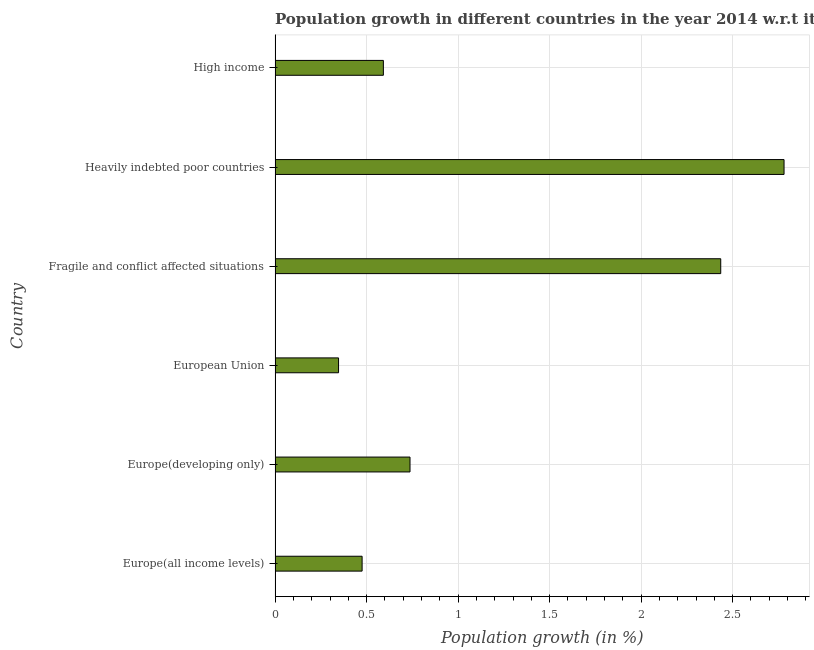Does the graph contain any zero values?
Give a very brief answer. No. Does the graph contain grids?
Offer a terse response. Yes. What is the title of the graph?
Offer a terse response. Population growth in different countries in the year 2014 w.r.t it's previous year. What is the label or title of the X-axis?
Your response must be concise. Population growth (in %). What is the population growth in Heavily indebted poor countries?
Provide a succinct answer. 2.78. Across all countries, what is the maximum population growth?
Your answer should be very brief. 2.78. Across all countries, what is the minimum population growth?
Keep it short and to the point. 0.35. In which country was the population growth maximum?
Give a very brief answer. Heavily indebted poor countries. What is the sum of the population growth?
Your answer should be very brief. 7.37. What is the difference between the population growth in Europe(developing only) and European Union?
Provide a succinct answer. 0.39. What is the average population growth per country?
Your answer should be compact. 1.23. What is the median population growth?
Your answer should be very brief. 0.66. What is the ratio of the population growth in European Union to that in Fragile and conflict affected situations?
Keep it short and to the point. 0.14. Is the population growth in Europe(all income levels) less than that in European Union?
Provide a succinct answer. No. What is the difference between the highest and the second highest population growth?
Make the answer very short. 0.35. Is the sum of the population growth in European Union and Heavily indebted poor countries greater than the maximum population growth across all countries?
Ensure brevity in your answer.  Yes. What is the difference between the highest and the lowest population growth?
Your response must be concise. 2.43. What is the difference between two consecutive major ticks on the X-axis?
Ensure brevity in your answer.  0.5. What is the Population growth (in %) in Europe(all income levels)?
Your response must be concise. 0.48. What is the Population growth (in %) of Europe(developing only)?
Your answer should be compact. 0.74. What is the Population growth (in %) of European Union?
Keep it short and to the point. 0.35. What is the Population growth (in %) in Fragile and conflict affected situations?
Ensure brevity in your answer.  2.43. What is the Population growth (in %) of Heavily indebted poor countries?
Offer a terse response. 2.78. What is the Population growth (in %) in High income?
Keep it short and to the point. 0.59. What is the difference between the Population growth (in %) in Europe(all income levels) and Europe(developing only)?
Your response must be concise. -0.26. What is the difference between the Population growth (in %) in Europe(all income levels) and European Union?
Ensure brevity in your answer.  0.13. What is the difference between the Population growth (in %) in Europe(all income levels) and Fragile and conflict affected situations?
Your response must be concise. -1.96. What is the difference between the Population growth (in %) in Europe(all income levels) and Heavily indebted poor countries?
Provide a succinct answer. -2.31. What is the difference between the Population growth (in %) in Europe(all income levels) and High income?
Your answer should be compact. -0.12. What is the difference between the Population growth (in %) in Europe(developing only) and European Union?
Give a very brief answer. 0.39. What is the difference between the Population growth (in %) in Europe(developing only) and Fragile and conflict affected situations?
Give a very brief answer. -1.7. What is the difference between the Population growth (in %) in Europe(developing only) and Heavily indebted poor countries?
Your answer should be compact. -2.04. What is the difference between the Population growth (in %) in Europe(developing only) and High income?
Offer a very short reply. 0.15. What is the difference between the Population growth (in %) in European Union and Fragile and conflict affected situations?
Your answer should be compact. -2.09. What is the difference between the Population growth (in %) in European Union and Heavily indebted poor countries?
Ensure brevity in your answer.  -2.43. What is the difference between the Population growth (in %) in European Union and High income?
Give a very brief answer. -0.24. What is the difference between the Population growth (in %) in Fragile and conflict affected situations and Heavily indebted poor countries?
Your answer should be very brief. -0.35. What is the difference between the Population growth (in %) in Fragile and conflict affected situations and High income?
Provide a short and direct response. 1.84. What is the difference between the Population growth (in %) in Heavily indebted poor countries and High income?
Keep it short and to the point. 2.19. What is the ratio of the Population growth (in %) in Europe(all income levels) to that in Europe(developing only)?
Ensure brevity in your answer.  0.65. What is the ratio of the Population growth (in %) in Europe(all income levels) to that in European Union?
Your answer should be very brief. 1.37. What is the ratio of the Population growth (in %) in Europe(all income levels) to that in Fragile and conflict affected situations?
Provide a succinct answer. 0.2. What is the ratio of the Population growth (in %) in Europe(all income levels) to that in Heavily indebted poor countries?
Ensure brevity in your answer.  0.17. What is the ratio of the Population growth (in %) in Europe(all income levels) to that in High income?
Give a very brief answer. 0.8. What is the ratio of the Population growth (in %) in Europe(developing only) to that in European Union?
Offer a very short reply. 2.13. What is the ratio of the Population growth (in %) in Europe(developing only) to that in Fragile and conflict affected situations?
Provide a short and direct response. 0.3. What is the ratio of the Population growth (in %) in Europe(developing only) to that in Heavily indebted poor countries?
Give a very brief answer. 0.27. What is the ratio of the Population growth (in %) in Europe(developing only) to that in High income?
Offer a very short reply. 1.25. What is the ratio of the Population growth (in %) in European Union to that in Fragile and conflict affected situations?
Provide a short and direct response. 0.14. What is the ratio of the Population growth (in %) in European Union to that in Heavily indebted poor countries?
Make the answer very short. 0.12. What is the ratio of the Population growth (in %) in European Union to that in High income?
Make the answer very short. 0.59. What is the ratio of the Population growth (in %) in Fragile and conflict affected situations to that in Heavily indebted poor countries?
Offer a terse response. 0.88. What is the ratio of the Population growth (in %) in Fragile and conflict affected situations to that in High income?
Make the answer very short. 4.12. What is the ratio of the Population growth (in %) in Heavily indebted poor countries to that in High income?
Provide a short and direct response. 4.7. 